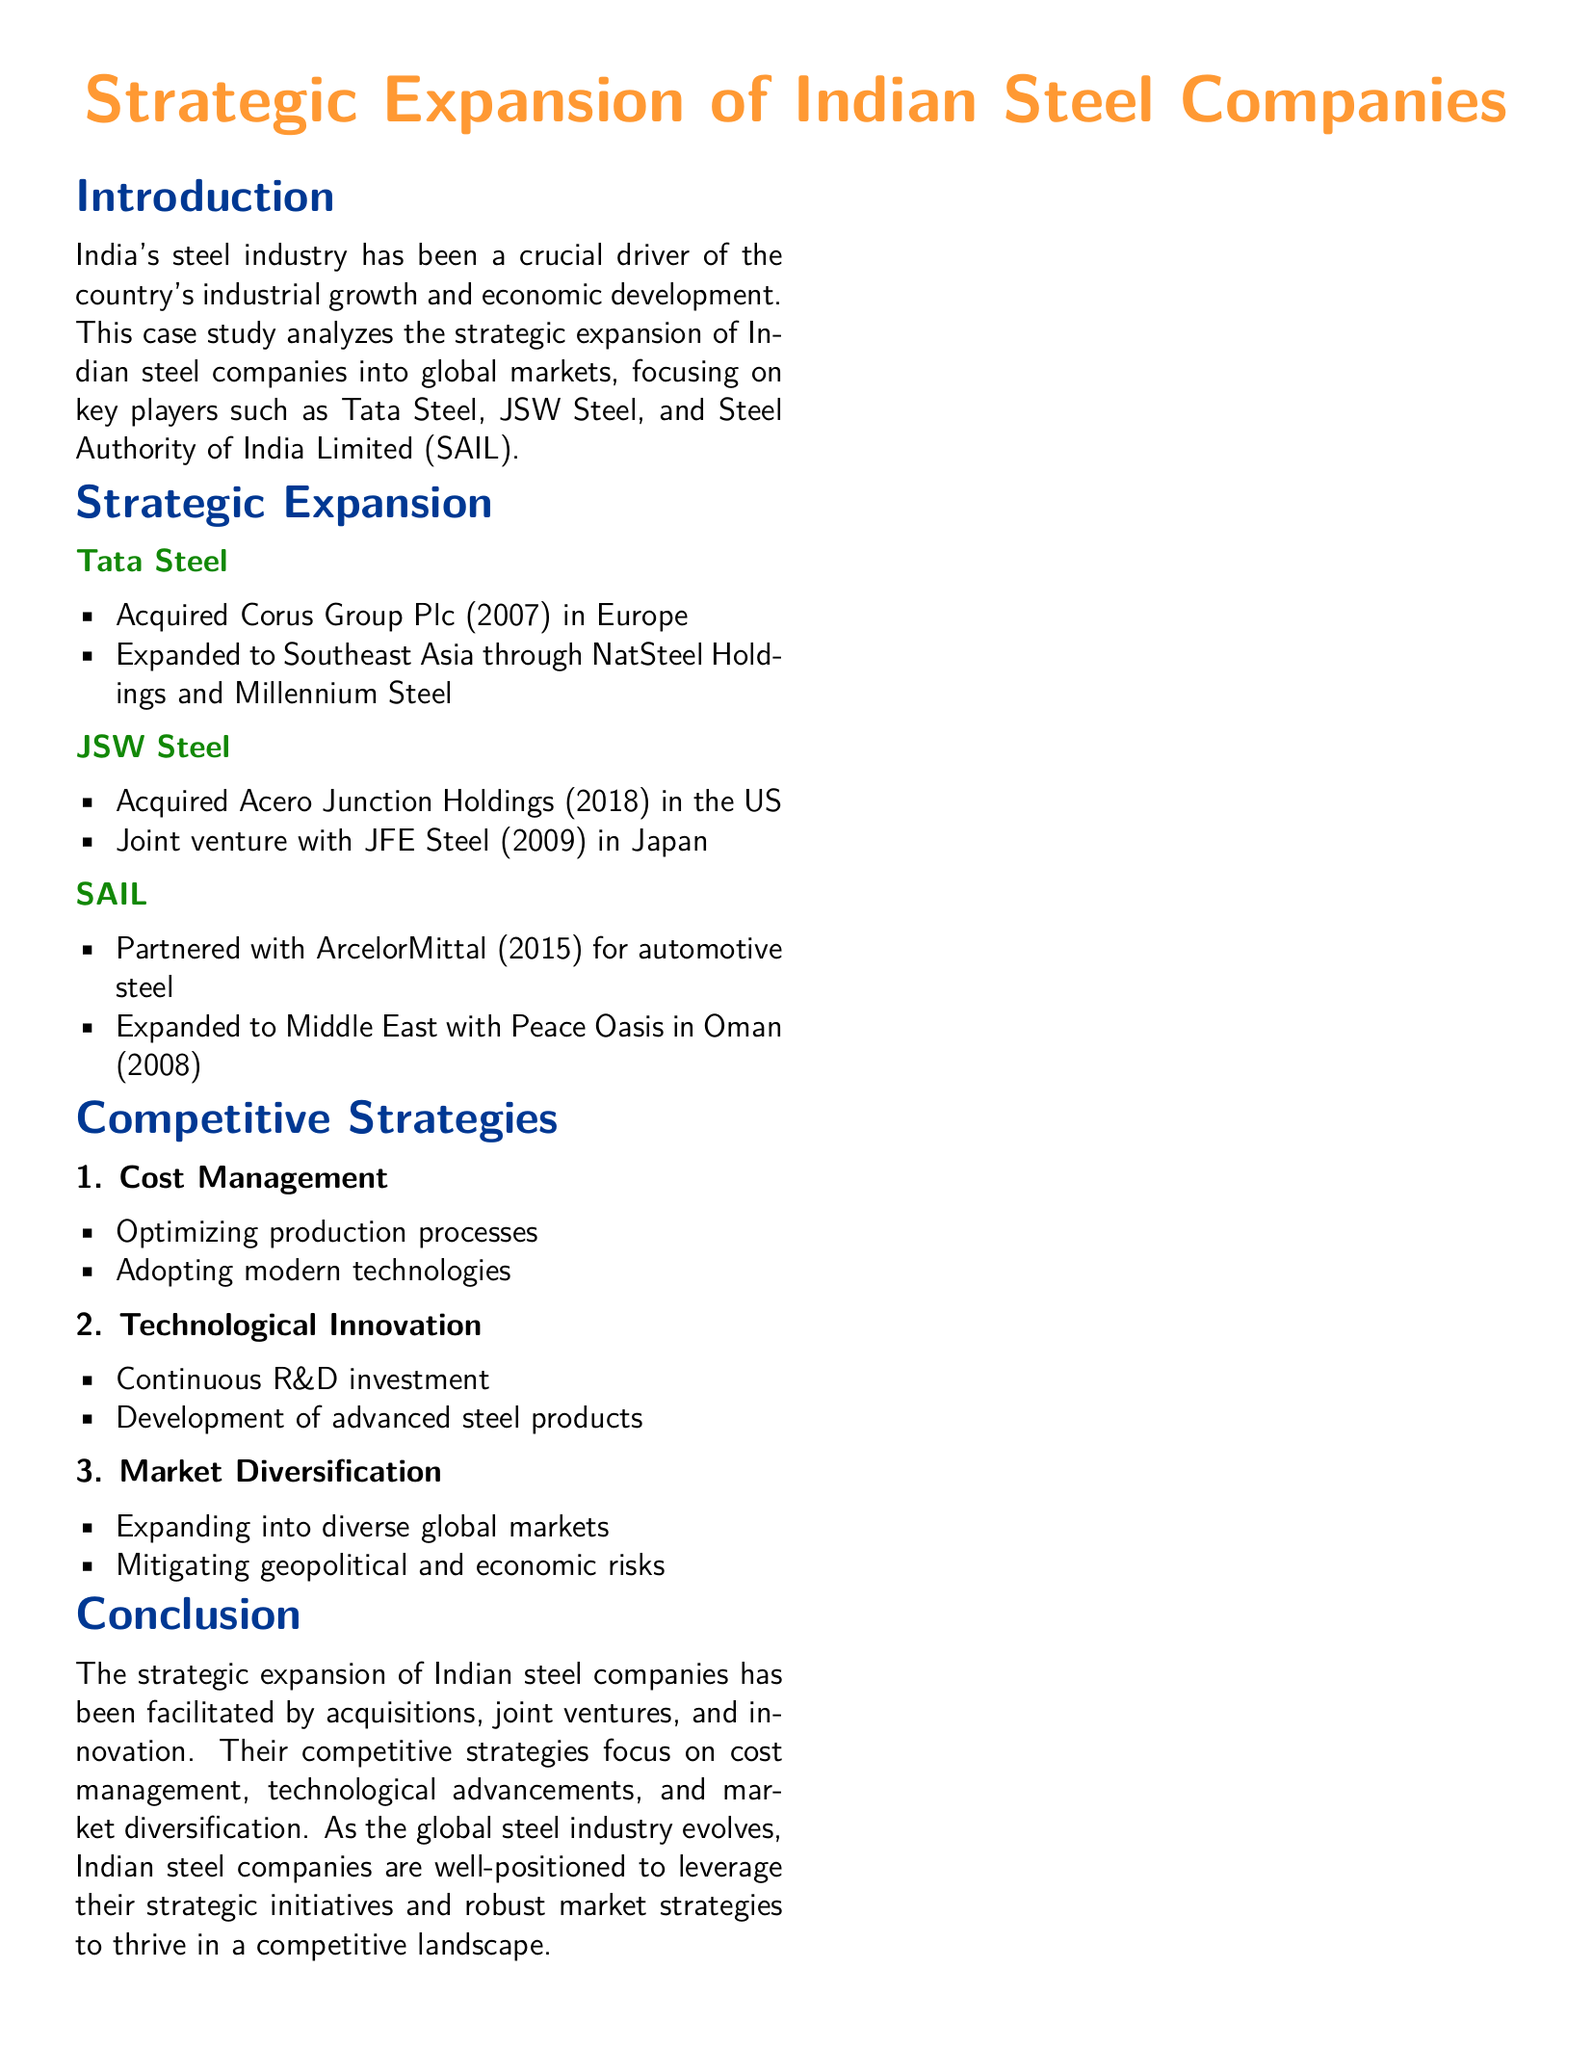What significant acquisition did Tata Steel make in 2007? The document states that Tata Steel acquired Corus Group Plc in 2007 in Europe.
Answer: Corus Group Plc Which Japanese company did JSW Steel form a joint venture with in 2009? The case study mentions JSW Steel's joint venture with JFE Steel in 2009 in Japan.
Answer: JFE Steel What key partnership did SAIL enter into in 2015? According to the document, SAIL partnered with ArcelorMittal for automotive steel in 2015.
Answer: ArcelorMittal What is one of the competitive strategies focused on by Indian steel companies? The document outlines multiple strategies, but one is cost management.
Answer: Cost management How many companies are specifically mentioned in the case study? The case study specifically mentions three companies: Tata Steel, JSW Steel, and SAIL.
Answer: Three What geographical region did Tata Steel expand into through NatSteel Holdings? The information indicates that Tata Steel expanded to Southeast Asia through NatSteel Holdings.
Answer: Southeast Asia What year was Peace Oasis established in Oman by SAIL? The document states that SAIL expanded to the Middle East with Peace Oasis in Oman in 2008.
Answer: 2008 Which area is highlighted for technological innovation in competitive strategies? The document mentions that continuous R&D investment is a focus area in technological innovation.
Answer: Continuous R&D investment What is the overall theme of the document? The case study centers around the strategic expansion of Indian steel companies into global markets.
Answer: Strategic expansion 